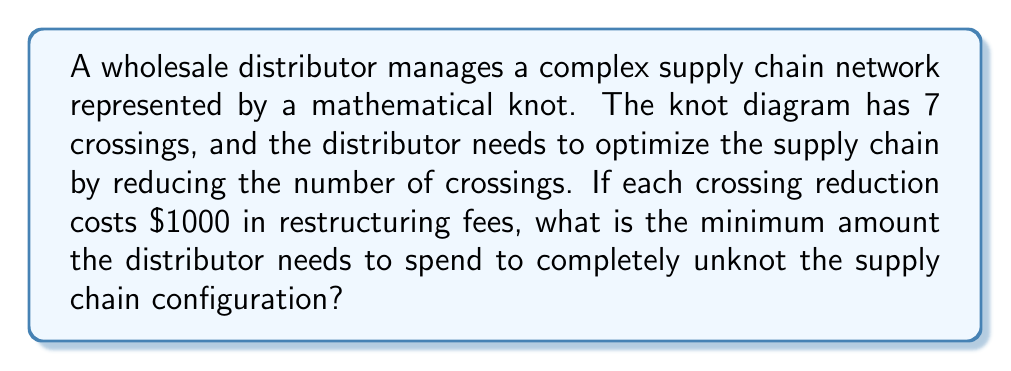Provide a solution to this math problem. To solve this problem, we need to determine the unknotting number of the given knot and then calculate the associated cost. Let's approach this step-by-step:

1) The unknotting number of a knot is the minimum number of crossing changes required to transform the knot into an unknot (also known as the trivial knot).

2) For a knot with 7 crossings, the maximum possible unknotting number would be 3. This is because:
   
   a) Any knot can be unknotted by changing at most half of its crossings.
   b) For a 7-crossing knot: $\lfloor \frac{7}{2} \rfloor = 3$

3) However, not all 7-crossing knots have an unknotting number of 3. The actual unknotting number could be 1, 2, or 3.

4) Without more specific information about the knot structure, we must assume the worst-case scenario, which is an unknotting number of 3.

5) Given that each crossing reduction costs $1000, the total cost would be:

   $$ \text{Total Cost} = \text{Unknotting Number} \times \text{Cost per Reduction} $$
   $$ \text{Total Cost} = 3 \times \$1000 = \$3000 $$

Therefore, the minimum amount the distributor needs to spend to completely unknot the supply chain configuration is $3000.
Answer: $3000 